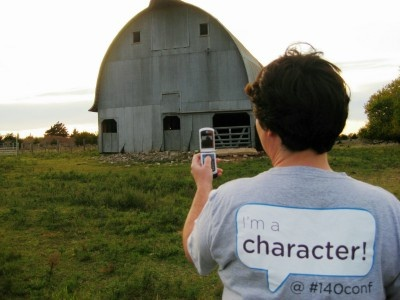Describe the objects in this image and their specific colors. I can see people in white, darkgray, black, and lightgray tones and cell phone in white, black, gray, and darkgray tones in this image. 